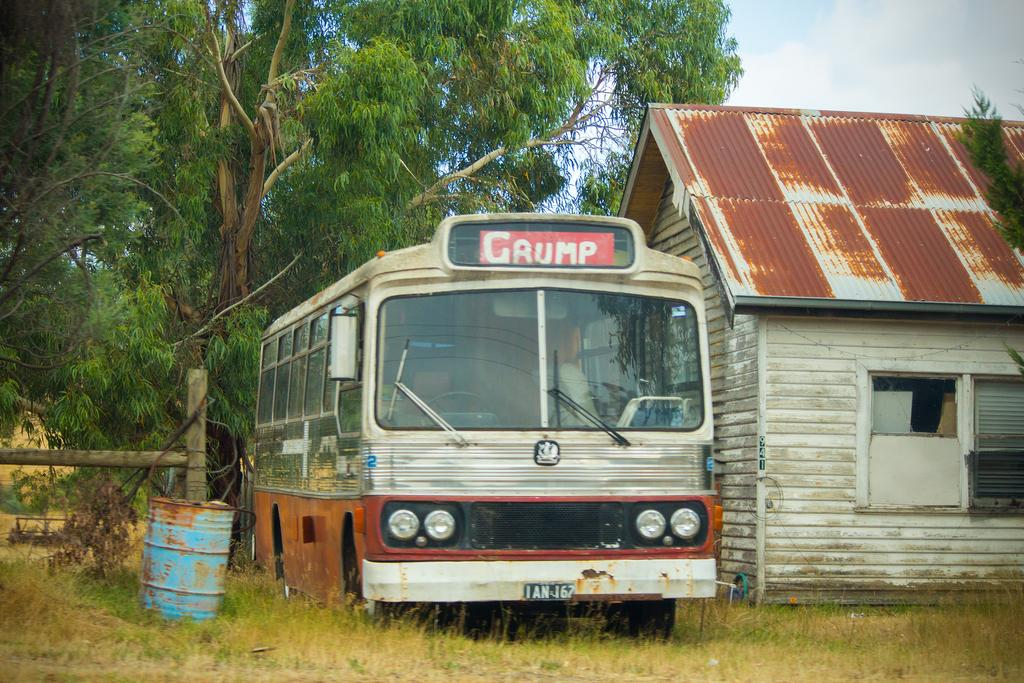<image>
Summarize the visual content of the image. An old bus has Grump written above the windshield. 